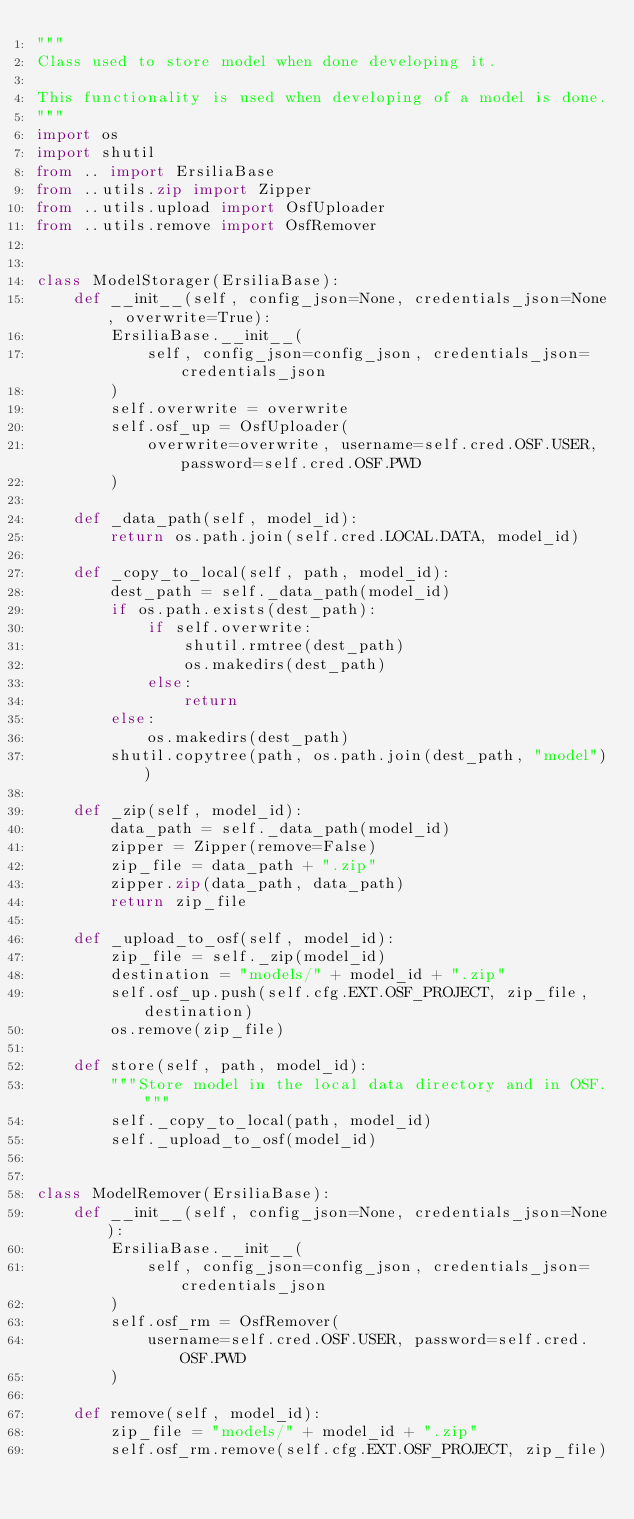Convert code to text. <code><loc_0><loc_0><loc_500><loc_500><_Python_>"""
Class used to store model when done developing it.

This functionality is used when developing of a model is done.
"""
import os
import shutil
from .. import ErsiliaBase
from ..utils.zip import Zipper
from ..utils.upload import OsfUploader
from ..utils.remove import OsfRemover


class ModelStorager(ErsiliaBase):
    def __init__(self, config_json=None, credentials_json=None, overwrite=True):
        ErsiliaBase.__init__(
            self, config_json=config_json, credentials_json=credentials_json
        )
        self.overwrite = overwrite
        self.osf_up = OsfUploader(
            overwrite=overwrite, username=self.cred.OSF.USER, password=self.cred.OSF.PWD
        )

    def _data_path(self, model_id):
        return os.path.join(self.cred.LOCAL.DATA, model_id)

    def _copy_to_local(self, path, model_id):
        dest_path = self._data_path(model_id)
        if os.path.exists(dest_path):
            if self.overwrite:
                shutil.rmtree(dest_path)
                os.makedirs(dest_path)
            else:
                return
        else:
            os.makedirs(dest_path)
        shutil.copytree(path, os.path.join(dest_path, "model"))

    def _zip(self, model_id):
        data_path = self._data_path(model_id)
        zipper = Zipper(remove=False)
        zip_file = data_path + ".zip"
        zipper.zip(data_path, data_path)
        return zip_file

    def _upload_to_osf(self, model_id):
        zip_file = self._zip(model_id)
        destination = "models/" + model_id + ".zip"
        self.osf_up.push(self.cfg.EXT.OSF_PROJECT, zip_file, destination)
        os.remove(zip_file)

    def store(self, path, model_id):
        """Store model in the local data directory and in OSF."""
        self._copy_to_local(path, model_id)
        self._upload_to_osf(model_id)


class ModelRemover(ErsiliaBase):
    def __init__(self, config_json=None, credentials_json=None):
        ErsiliaBase.__init__(
            self, config_json=config_json, credentials_json=credentials_json
        )
        self.osf_rm = OsfRemover(
            username=self.cred.OSF.USER, password=self.cred.OSF.PWD
        )

    def remove(self, model_id):
        zip_file = "models/" + model_id + ".zip"
        self.osf_rm.remove(self.cfg.EXT.OSF_PROJECT, zip_file)
</code> 